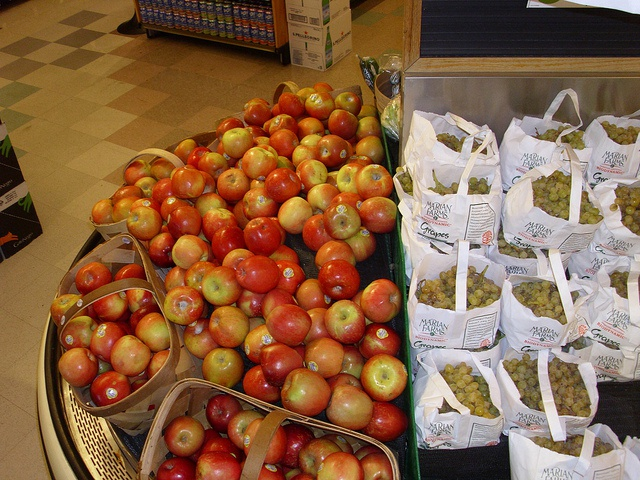Describe the objects in this image and their specific colors. I can see apple in black, brown, maroon, and red tones, apple in black, red, brown, and orange tones, apple in black, red, tan, maroon, and orange tones, apple in black, brown, maroon, and orange tones, and apple in black, maroon, brown, and red tones in this image. 